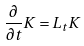<formula> <loc_0><loc_0><loc_500><loc_500>\frac { \partial } { \partial t } K = L _ { t } K</formula> 